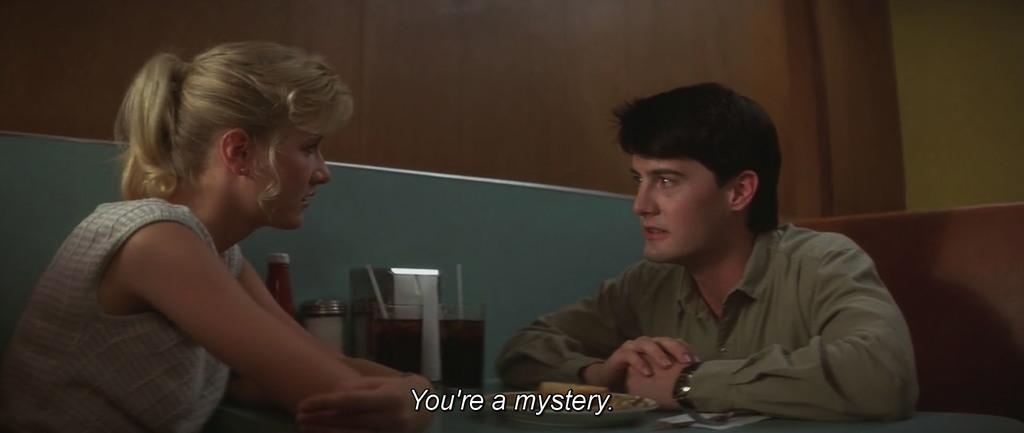What are the two persons in the image doing? The two persons in the image are sitting and talking. What objects can be seen between the two persons? There are drinks and bottles in the middle of the image. What is visible in the background of the image? There is a wall in the background of the image. What type of paper is being used to frame the conversation in the image? There is no paper or frame present in the image; it is a candid shot of two persons sitting and talking. 